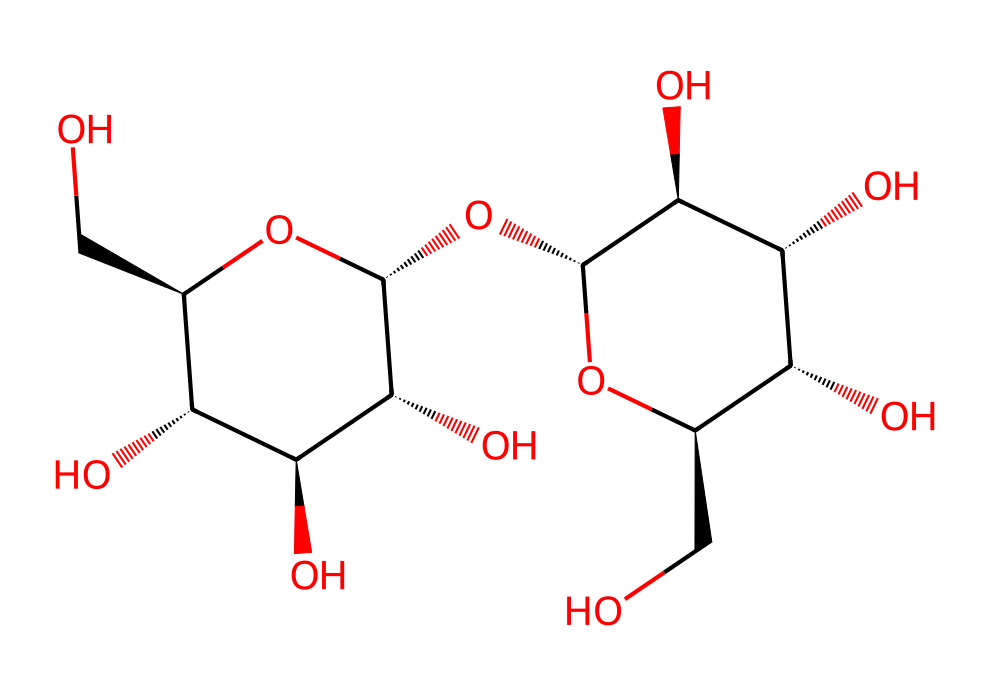what is the molecular formula of this compound? To find the molecular formula, count the number of each type of atom based on the chemical structure represented by the SMILES. The structure reveals various hydroxyl groups and carbon atoms typically found in carbohydrates. Thus, the counts lead to the formula C6H12O6.
Answer: C6H12O6 how many carbon atoms are present in the structure? The chemical structure contains six interconnected carbon atoms. This can be determined by identifying each carbon (C) that is part of the sugar units within the structure.
Answer: 6 what type of carbohydrate is maltodextrin classified as? Maltodextrin is classified as a polysaccharide because it is made up of several glucose units connected together, which is characteristic of complex carbohydrates.
Answer: polysaccharide how many oxygen atoms are found in this molecule? By systematically counting the oxygen (O) atoms in the structure represented, there are six oxygen atoms present in the entire molecular structure.
Answer: 6 what is the primary function of maltodextrin in food products like protein bars? Maltodextrin primarily serves as a carbohydrate source, providing energy and acting as a food thickener or filler in protein bars. Its role as a quick source of energy is essential for athletes.
Answer: energy source does this structure contain any hydroxyl groups? Yes, the structure contains several hydroxyl (-OH) groups, indicated by the presence of oxygen and hydrogen atoms in the chemical formula. These groups are responsible for the solubility and functionality of the carbohydrate.
Answer: yes 